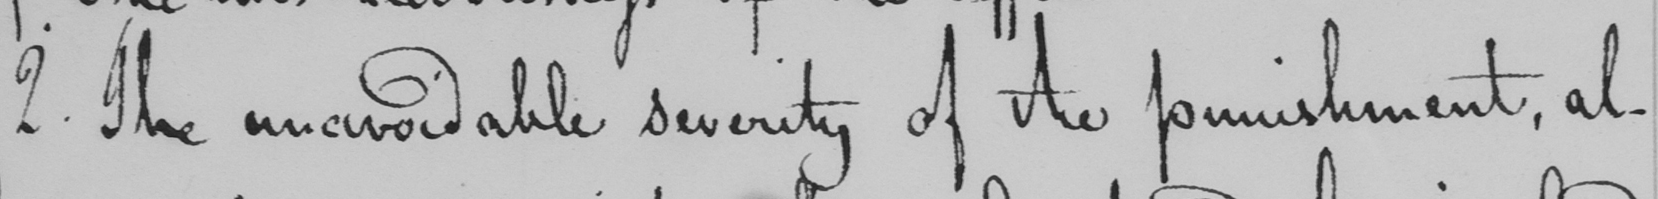Transcribe the text shown in this historical manuscript line. 2 . The unavoidable severity of the punishment , al- 